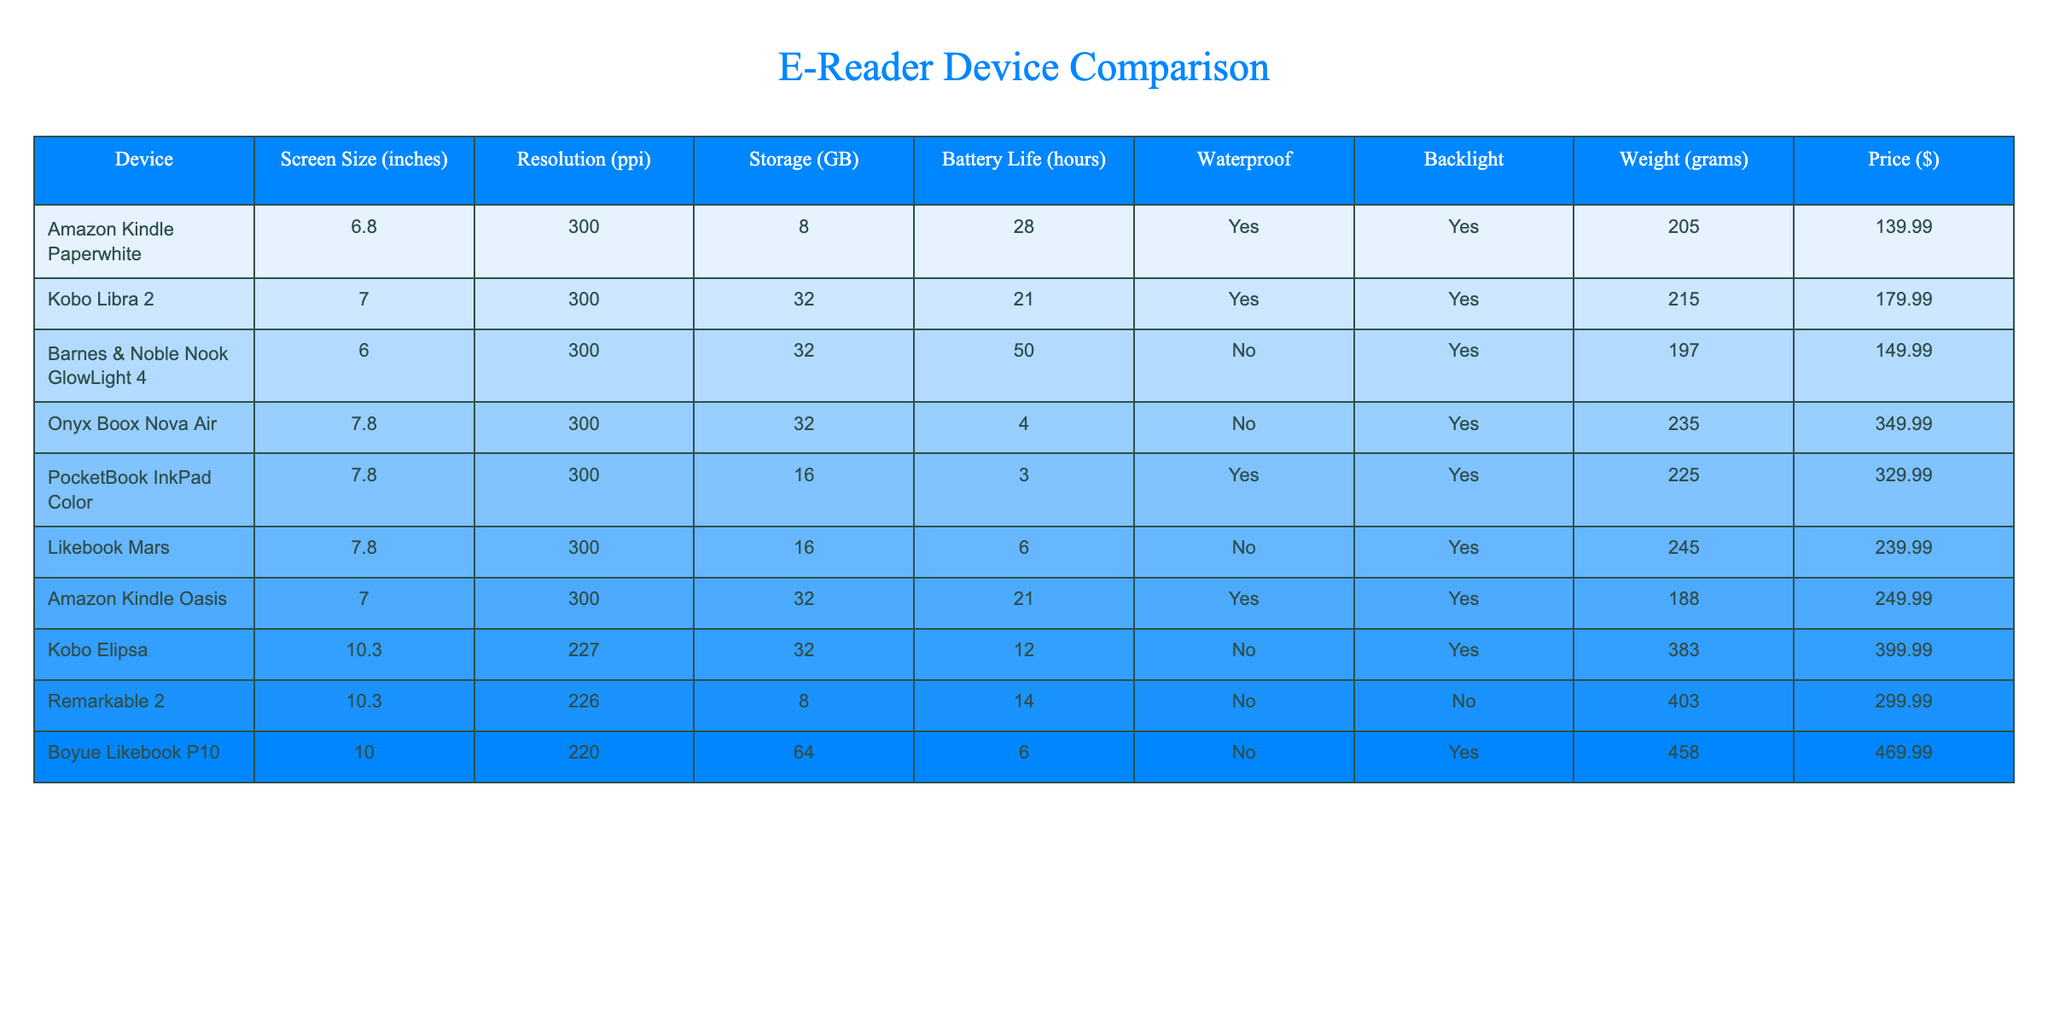What is the weight of the Kobo Libra 2? By looking at the table, we can see the row corresponding to Kobo Libra 2, which lists its weight as 215 grams.
Answer: 215 grams Which device has the longest battery life? The table shows the battery life for each device. The Barnes & Noble Nook GlowLight 4 has a battery life of 50 hours, which is the highest among all listed devices.
Answer: 50 hours Are any devices waterproof? The table indicates whether devices are waterproof with a "Yes" or "No" in the corresponding column. The Amazon Kindle Paperwhite, Kobo Libra 2, Barnes & Noble Nook GlowLight 4, Amazon Kindle Oasis, and Kobo Elipsa are listed as waterproof.
Answer: Yes What is the average screen size of the devices? To find the average screen size, we add the screen sizes of all devices: (6.8 + 7 + 6 + 7.8 + 7.8 + 7.8 + 7 + 10.3 + 10.3 + 10) = 79.4 inches. We then divide by the number of devices, which is 10. So, 79.4 / 10 = 7.94 inches.
Answer: 7.94 inches Which device has the lowest resolution? We compare the resolution values listed in the table. The Kobo Elipsa and Boyue Likebook P10 have the lowest resolution of 220 ppi.
Answer: 220 ppi What is the price difference between the most expensive and the least expensive devices? The most expensive device is the Boyue Likebook P10 priced at $469.99, and the least expensive is the Amazon Kindle Paperwhite priced at $139.99. The price difference is $469.99 - $139.99 = $330.
Answer: $330 How many devices have at least 32 GB of storage? We look at the storage column and count how many devices have a storage value of 32 GB or more. The devices are Kobo Libra 2, Barnes & Noble Nook GlowLight 4, Amazon Kindle Oasis, Kobo Elipsa, and Boyue Likebook P10, resulting in a total of 5 devices.
Answer: 5 devices What is the weighted average price of devices that are waterproof? First, we identify the waterproof devices and their prices: Amazon Kindle Paperwhite ($139.99), Kobo Libra 2 ($179.99), Barnes & Noble Nook GlowLight 4 ($149.99), and Amazon Kindle Oasis ($249.99). Their total price is $139.99 + $179.99 + $149.99 + $249.99 = $719.96. There are 4 waterproof devices, so the weighted average price is $719.96 / 4 = $179.99.
Answer: $179.99 Which device has the smallest storage capacity? In the table, we check the storage column to find the smallest value. The Amazon Kindle Paperwhite has the smallest storage capacity of 8 GB.
Answer: 8 GB How much does the Kobo Elipsa weigh compared to the lightest device? From the table, we see the Kobo Elipsa weighs 383 grams. The lightest device is the Barnes & Noble Nook GlowLight 4, which is 197 grams. The weight difference is 383 - 197 = 186 grams.
Answer: 186 grams 